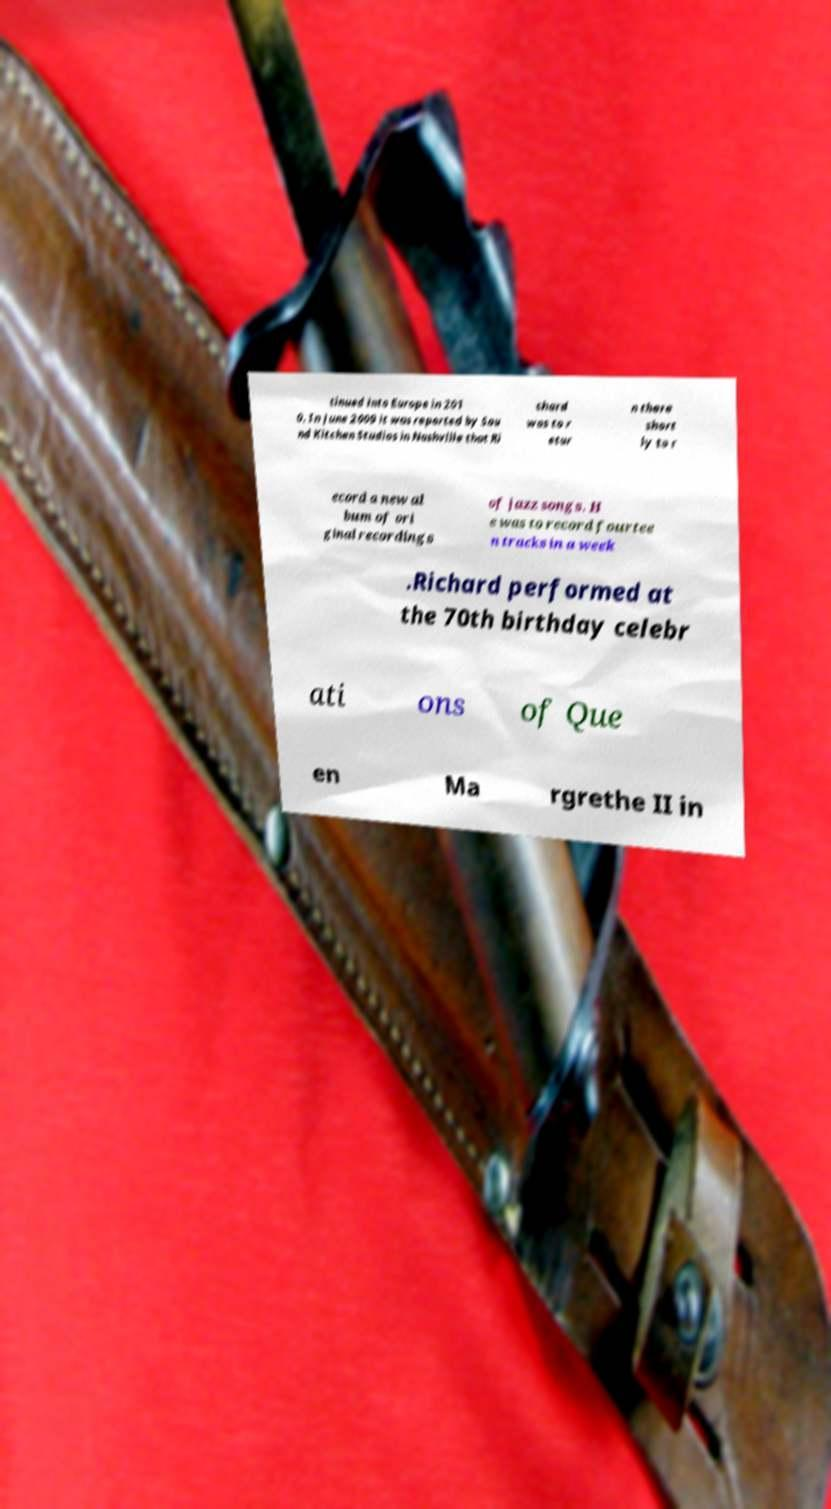Could you extract and type out the text from this image? tinued into Europe in 201 0. In June 2009 it was reported by Sou nd Kitchen Studios in Nashville that Ri chard was to r etur n there short ly to r ecord a new al bum of ori ginal recordings of jazz songs. H e was to record fourtee n tracks in a week .Richard performed at the 70th birthday celebr ati ons of Que en Ma rgrethe II in 